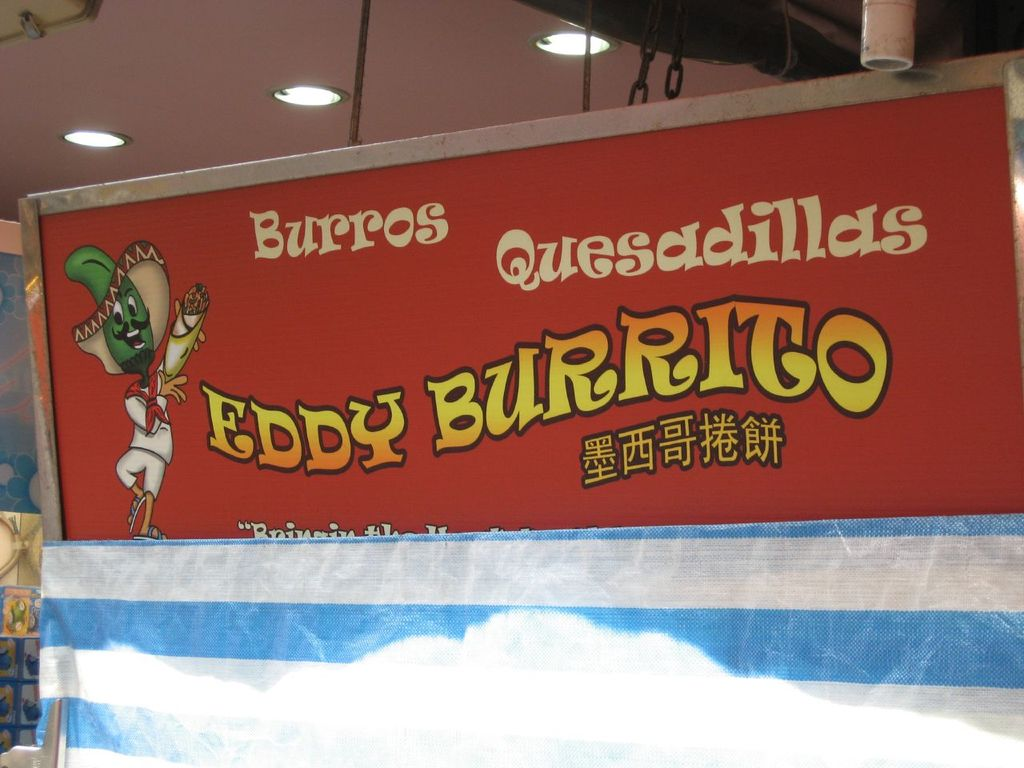What do you think is going on in this snapshot? This image features a vibrant, eye-catching sign for a restaurant named 'Eddy Burrito'. The sign is adorned with a large, playful illustration of a green lizard character wearing a sombrero and holding a burrito, symbolizing the Mexican-themed cuisine. Highlighted in bold red with yellow lettering, the sign advertises burritos and quesadillas as its specialty. The tagline 'Bringing the taste of Mexico to Hong Kong' is also prominently displayed, suggesting an endeavor to fuse Mexican culinary traditions with the local culture of Hong Kong. The presence of additional elements like a blue awning hints at a street food setting, possibly in a busy market area, inviting local patrons and tourists to savor authentic Mexican flavors in a vibrant and informal environment. 